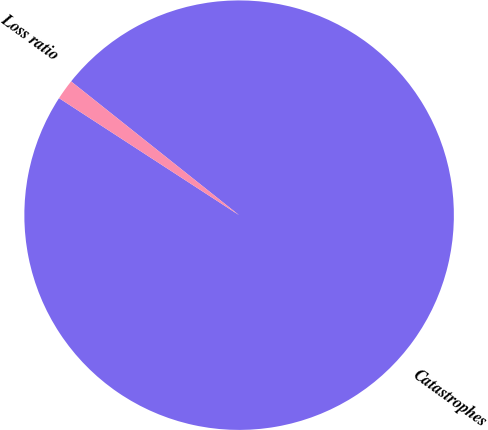Convert chart. <chart><loc_0><loc_0><loc_500><loc_500><pie_chart><fcel>Catastrophes<fcel>Loss ratio<nl><fcel>98.47%<fcel>1.53%<nl></chart> 